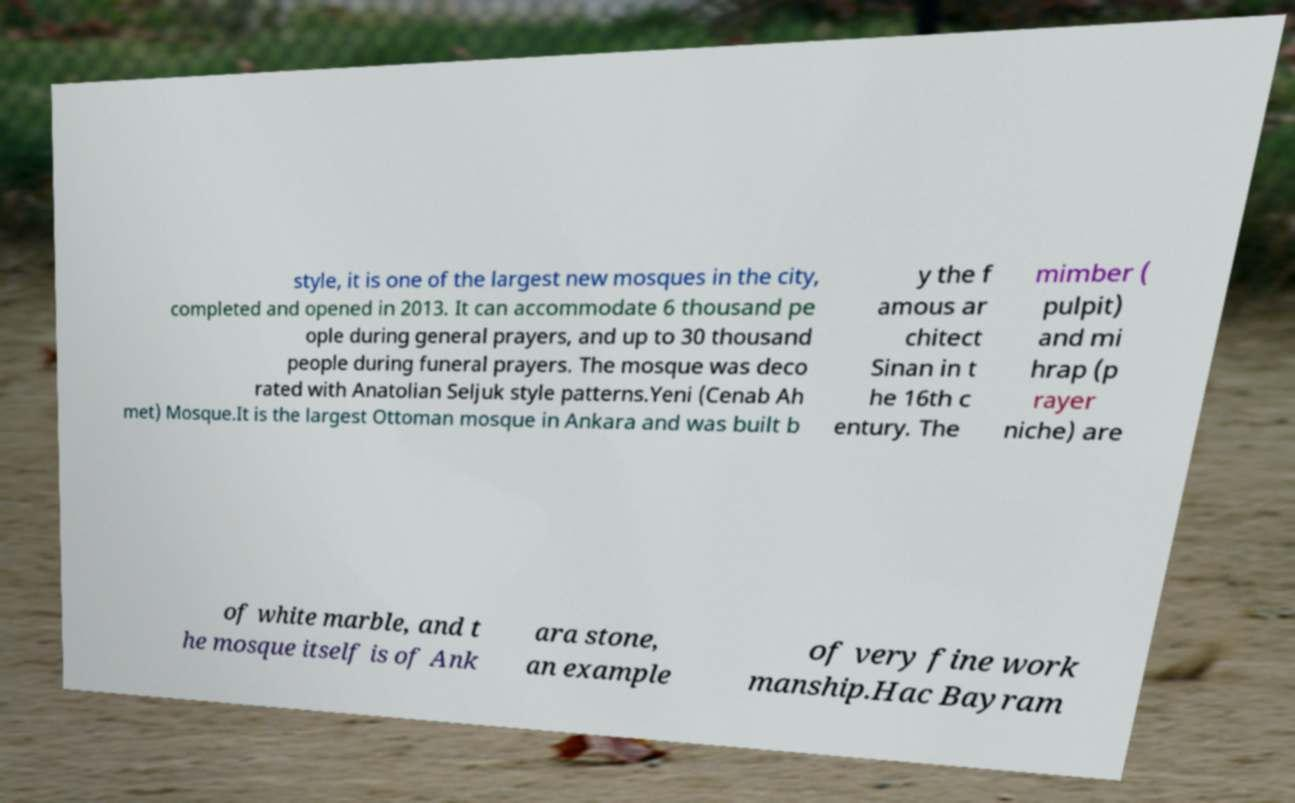Please read and relay the text visible in this image. What does it say? style, it is one of the largest new mosques in the city, completed and opened in 2013. It can accommodate 6 thousand pe ople during general prayers, and up to 30 thousand people during funeral prayers. The mosque was deco rated with Anatolian Seljuk style patterns.Yeni (Cenab Ah met) Mosque.It is the largest Ottoman mosque in Ankara and was built b y the f amous ar chitect Sinan in t he 16th c entury. The mimber ( pulpit) and mi hrap (p rayer niche) are of white marble, and t he mosque itself is of Ank ara stone, an example of very fine work manship.Hac Bayram 